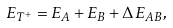Convert formula to latex. <formula><loc_0><loc_0><loc_500><loc_500>E _ { T ^ { + } } = E _ { A } + E _ { B } + \Delta \, E _ { A B } ,</formula> 